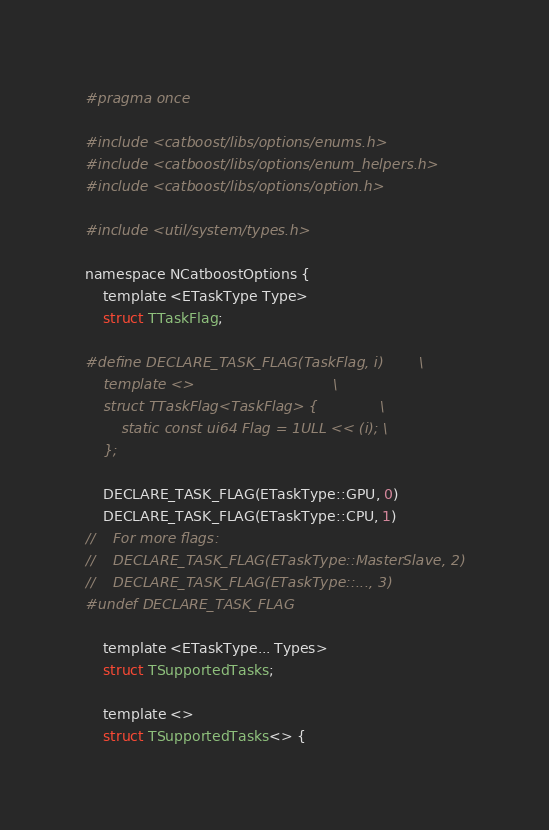<code> <loc_0><loc_0><loc_500><loc_500><_C_>#pragma once

#include <catboost/libs/options/enums.h>
#include <catboost/libs/options/enum_helpers.h>
#include <catboost/libs/options/option.h>

#include <util/system/types.h>

namespace NCatboostOptions {
    template <ETaskType Type>
    struct TTaskFlag;

#define DECLARE_TASK_FLAG(TaskFlag, i)        \
    template <>                               \
    struct TTaskFlag<TaskFlag> {              \
        static const ui64 Flag = 1ULL << (i); \
    };

    DECLARE_TASK_FLAG(ETaskType::GPU, 0)
    DECLARE_TASK_FLAG(ETaskType::CPU, 1)
//    For more flags:
//    DECLARE_TASK_FLAG(ETaskType::MasterSlave, 2)
//    DECLARE_TASK_FLAG(ETaskType::..., 3)
#undef DECLARE_TASK_FLAG

    template <ETaskType... Types>
    struct TSupportedTasks;

    template <>
    struct TSupportedTasks<> {</code> 